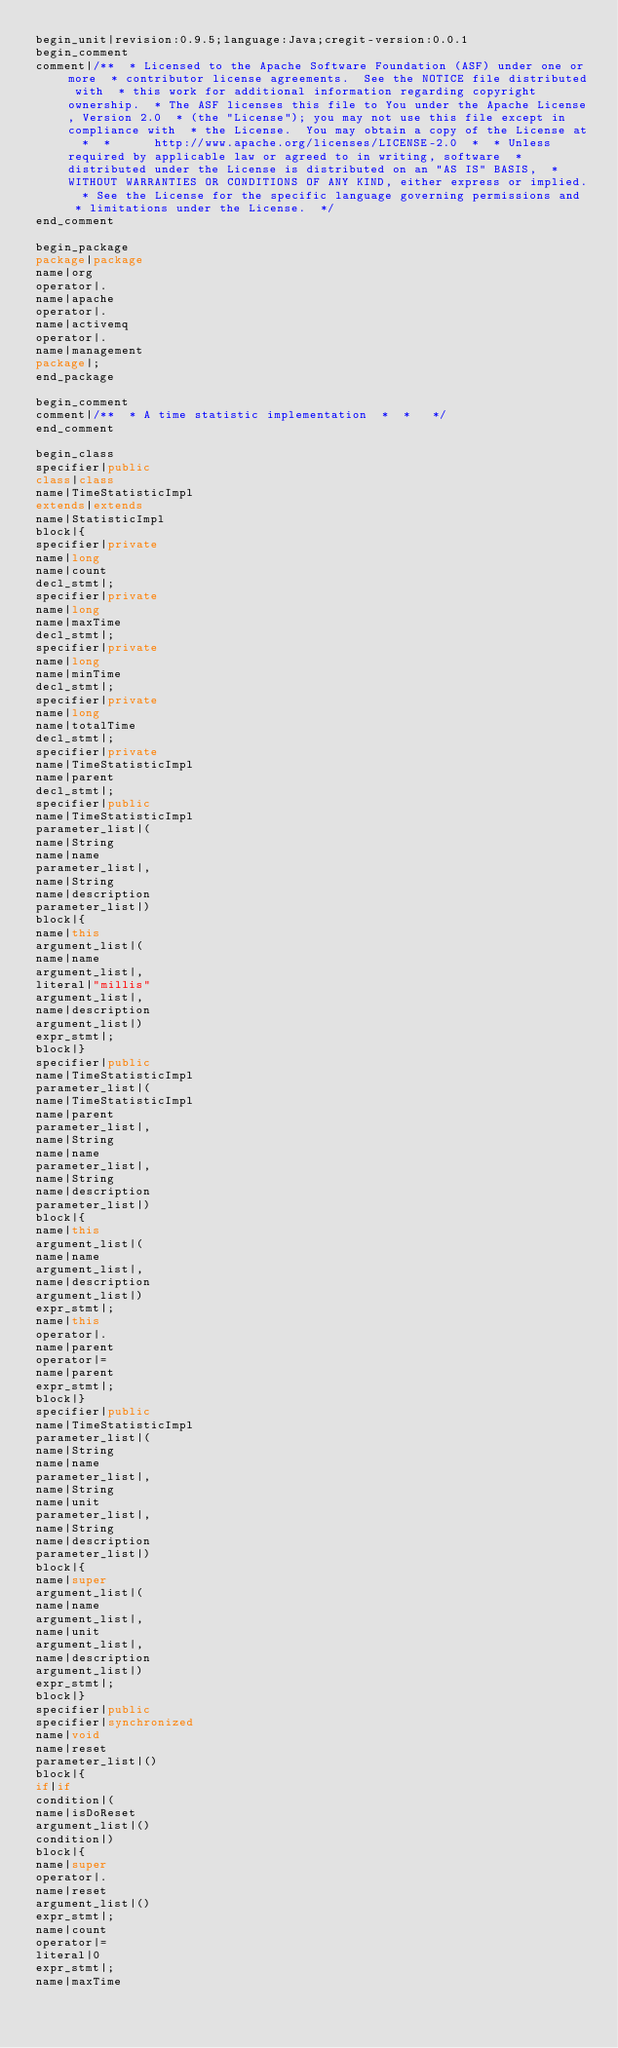<code> <loc_0><loc_0><loc_500><loc_500><_Java_>begin_unit|revision:0.9.5;language:Java;cregit-version:0.0.1
begin_comment
comment|/**  * Licensed to the Apache Software Foundation (ASF) under one or more  * contributor license agreements.  See the NOTICE file distributed with  * this work for additional information regarding copyright ownership.  * The ASF licenses this file to You under the Apache License, Version 2.0  * (the "License"); you may not use this file except in compliance with  * the License.  You may obtain a copy of the License at  *  *      http://www.apache.org/licenses/LICENSE-2.0  *  * Unless required by applicable law or agreed to in writing, software  * distributed under the License is distributed on an "AS IS" BASIS,  * WITHOUT WARRANTIES OR CONDITIONS OF ANY KIND, either express or implied.  * See the License for the specific language governing permissions and  * limitations under the License.  */
end_comment

begin_package
package|package
name|org
operator|.
name|apache
operator|.
name|activemq
operator|.
name|management
package|;
end_package

begin_comment
comment|/**  * A time statistic implementation  *  *   */
end_comment

begin_class
specifier|public
class|class
name|TimeStatisticImpl
extends|extends
name|StatisticImpl
block|{
specifier|private
name|long
name|count
decl_stmt|;
specifier|private
name|long
name|maxTime
decl_stmt|;
specifier|private
name|long
name|minTime
decl_stmt|;
specifier|private
name|long
name|totalTime
decl_stmt|;
specifier|private
name|TimeStatisticImpl
name|parent
decl_stmt|;
specifier|public
name|TimeStatisticImpl
parameter_list|(
name|String
name|name
parameter_list|,
name|String
name|description
parameter_list|)
block|{
name|this
argument_list|(
name|name
argument_list|,
literal|"millis"
argument_list|,
name|description
argument_list|)
expr_stmt|;
block|}
specifier|public
name|TimeStatisticImpl
parameter_list|(
name|TimeStatisticImpl
name|parent
parameter_list|,
name|String
name|name
parameter_list|,
name|String
name|description
parameter_list|)
block|{
name|this
argument_list|(
name|name
argument_list|,
name|description
argument_list|)
expr_stmt|;
name|this
operator|.
name|parent
operator|=
name|parent
expr_stmt|;
block|}
specifier|public
name|TimeStatisticImpl
parameter_list|(
name|String
name|name
parameter_list|,
name|String
name|unit
parameter_list|,
name|String
name|description
parameter_list|)
block|{
name|super
argument_list|(
name|name
argument_list|,
name|unit
argument_list|,
name|description
argument_list|)
expr_stmt|;
block|}
specifier|public
specifier|synchronized
name|void
name|reset
parameter_list|()
block|{
if|if
condition|(
name|isDoReset
argument_list|()
condition|)
block|{
name|super
operator|.
name|reset
argument_list|()
expr_stmt|;
name|count
operator|=
literal|0
expr_stmt|;
name|maxTime</code> 